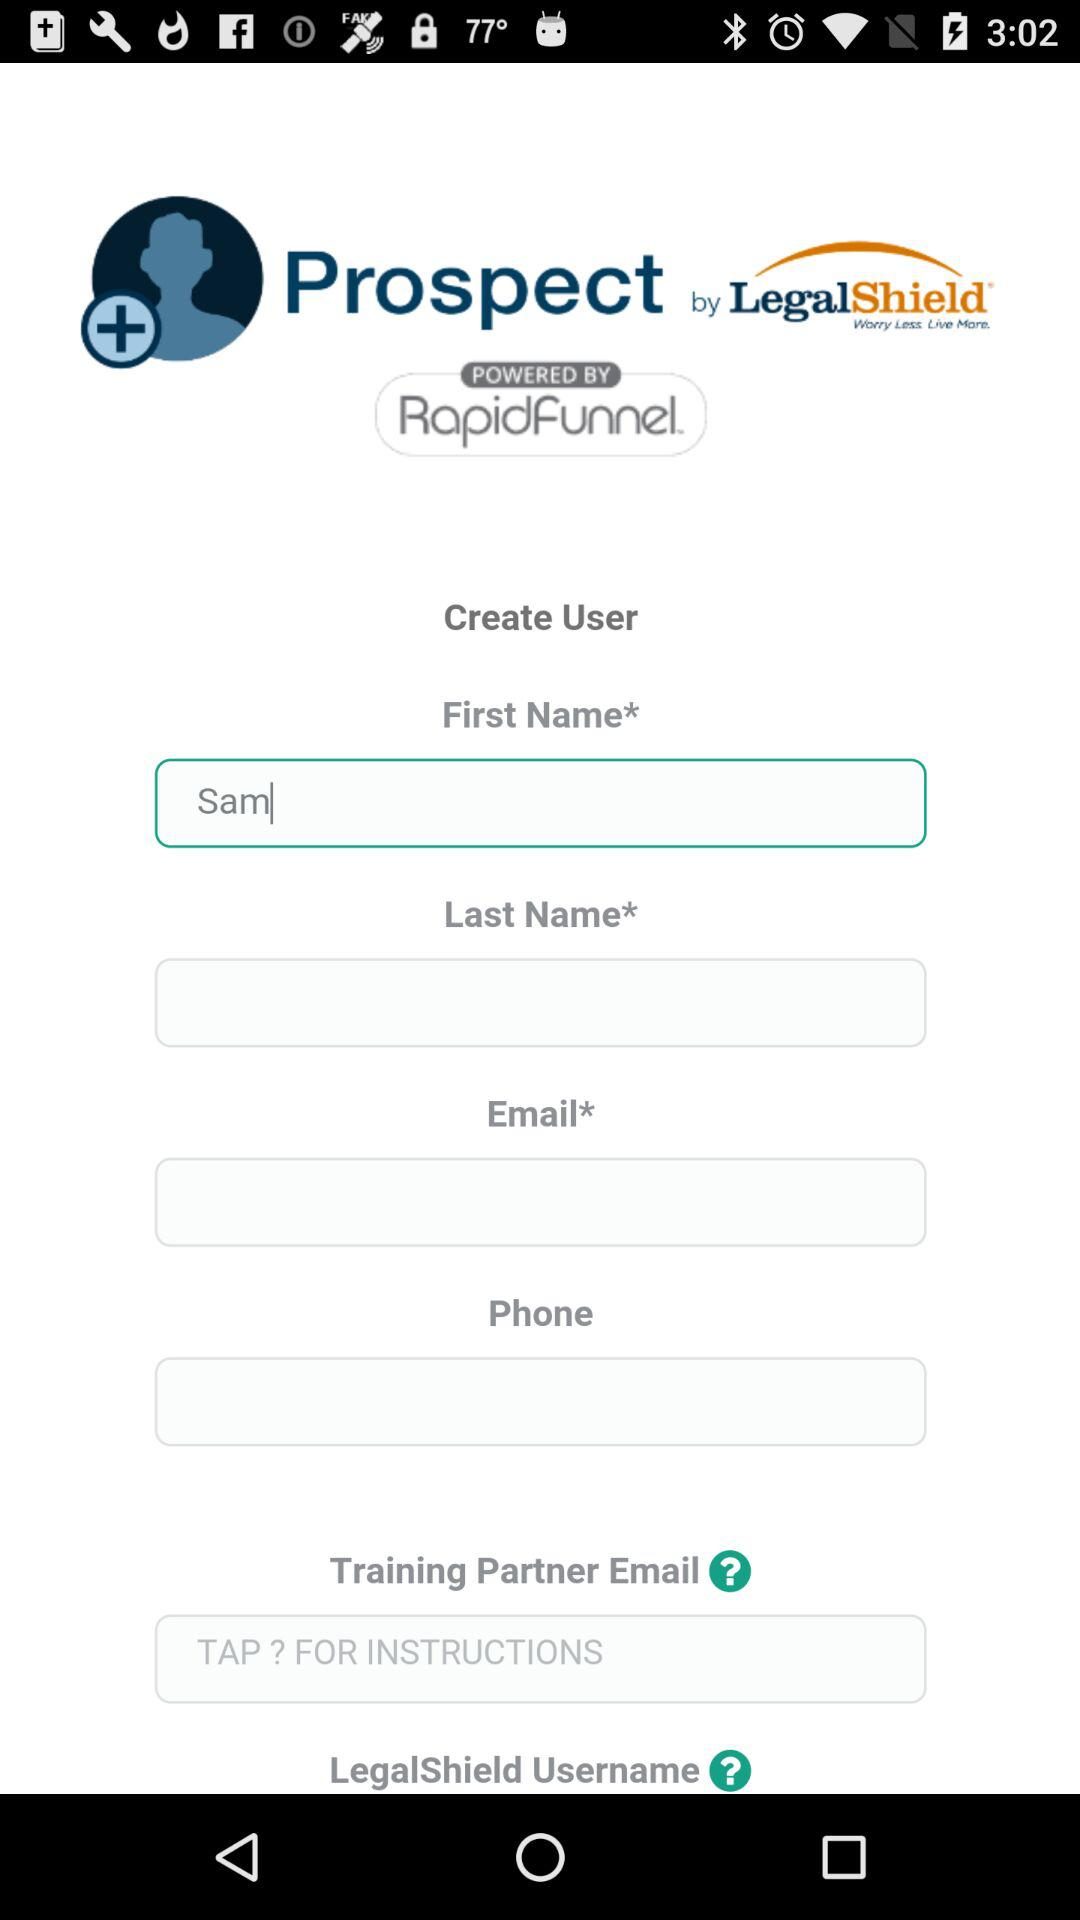How many fields are required for the user creation form?
Answer the question using a single word or phrase. 5 